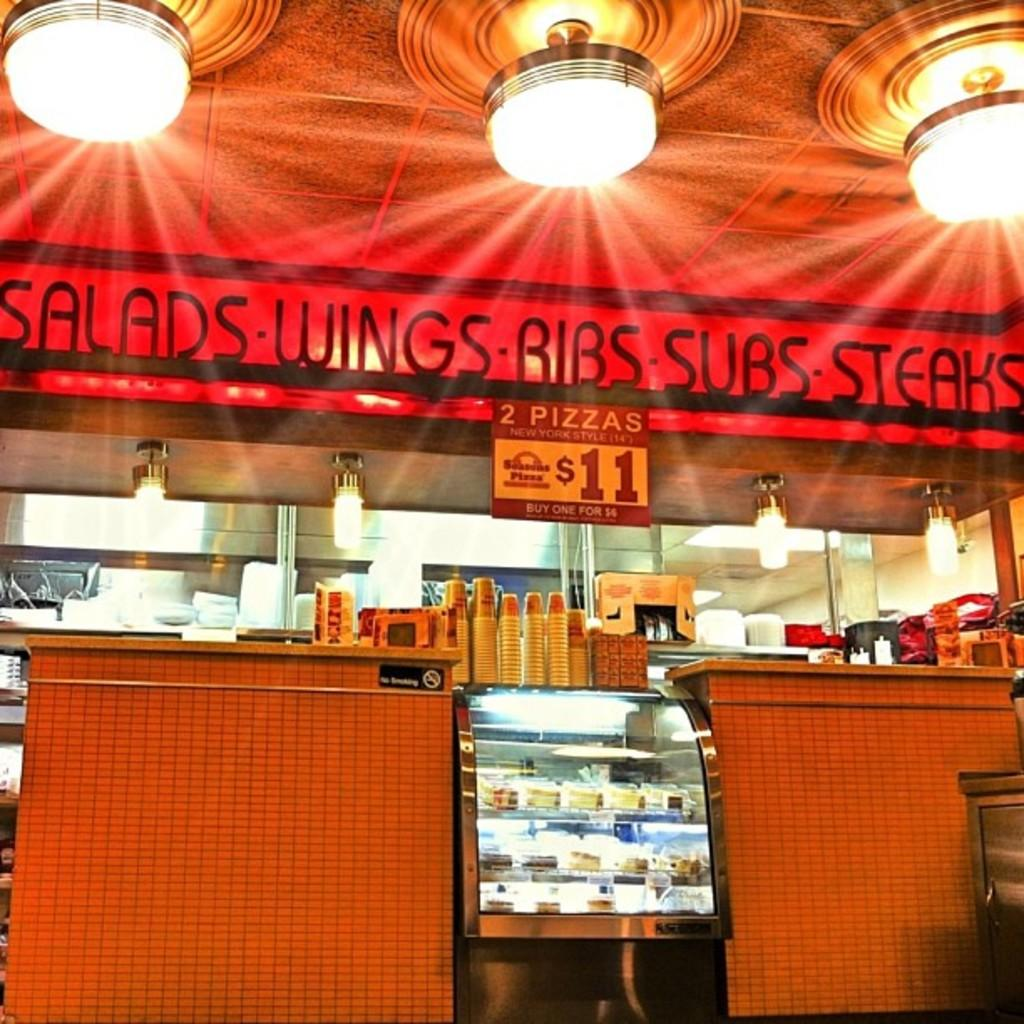<image>
Offer a succinct explanation of the picture presented. The restaurant sells salads, wings, ribs, subs, steaks and pizza. 